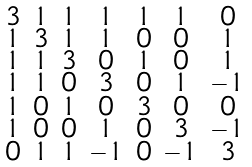Convert formula to latex. <formula><loc_0><loc_0><loc_500><loc_500>\begin{smallmatrix} 3 & 1 & 1 & 1 & 1 & 1 & 0 \\ 1 & 3 & 1 & 1 & 0 & 0 & 1 \\ 1 & 1 & 3 & 0 & 1 & 0 & 1 \\ 1 & 1 & 0 & 3 & 0 & 1 & - 1 \\ 1 & 0 & 1 & 0 & 3 & 0 & 0 \\ 1 & 0 & 0 & 1 & 0 & 3 & - 1 \\ 0 & 1 & 1 & - 1 & 0 & - 1 & 3 \end{smallmatrix}</formula> 